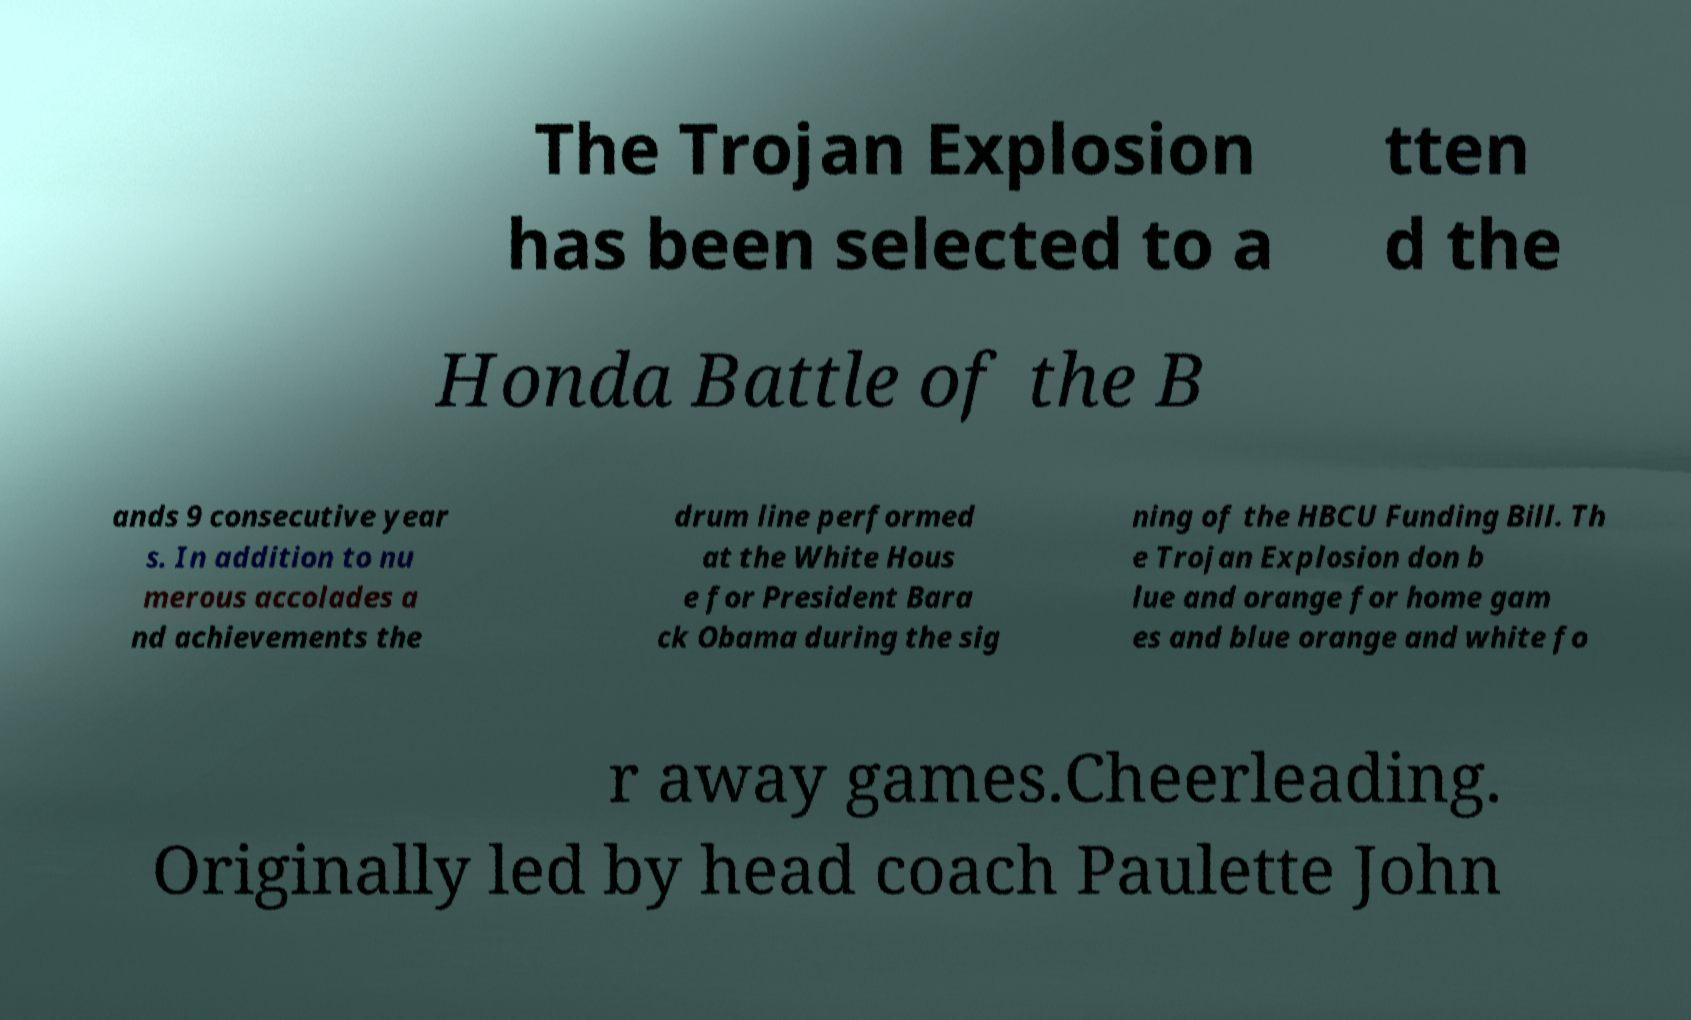There's text embedded in this image that I need extracted. Can you transcribe it verbatim? The Trojan Explosion has been selected to a tten d the Honda Battle of the B ands 9 consecutive year s. In addition to nu merous accolades a nd achievements the drum line performed at the White Hous e for President Bara ck Obama during the sig ning of the HBCU Funding Bill. Th e Trojan Explosion don b lue and orange for home gam es and blue orange and white fo r away games.Cheerleading. Originally led by head coach Paulette John 